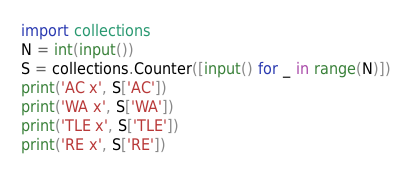<code> <loc_0><loc_0><loc_500><loc_500><_Python_>import collections
N = int(input())
S = collections.Counter([input() for _ in range(N)])
print('AC x', S['AC'])
print('WA x', S['WA'])
print('TLE x', S['TLE'])
print('RE x', S['RE'])
</code> 